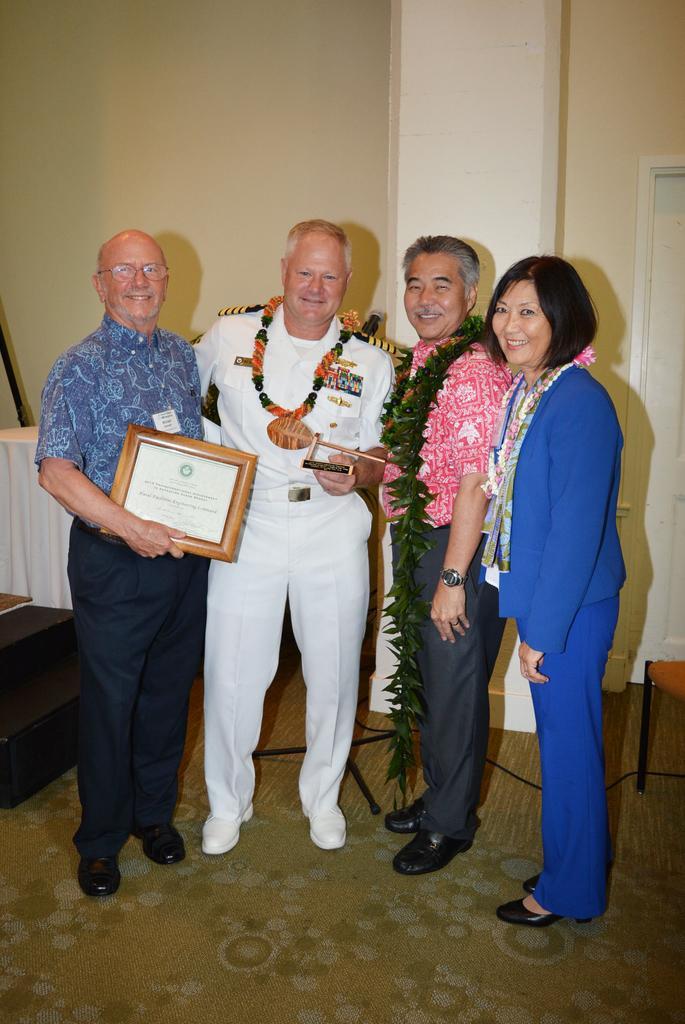How would you summarize this image in a sentence or two? Floor with carpet. These four people are standing. This man is holding a certificate, another man is holding an object. Background we can see wall, door, table and chair. On this there is a cloth. On the floor there is a cable.  